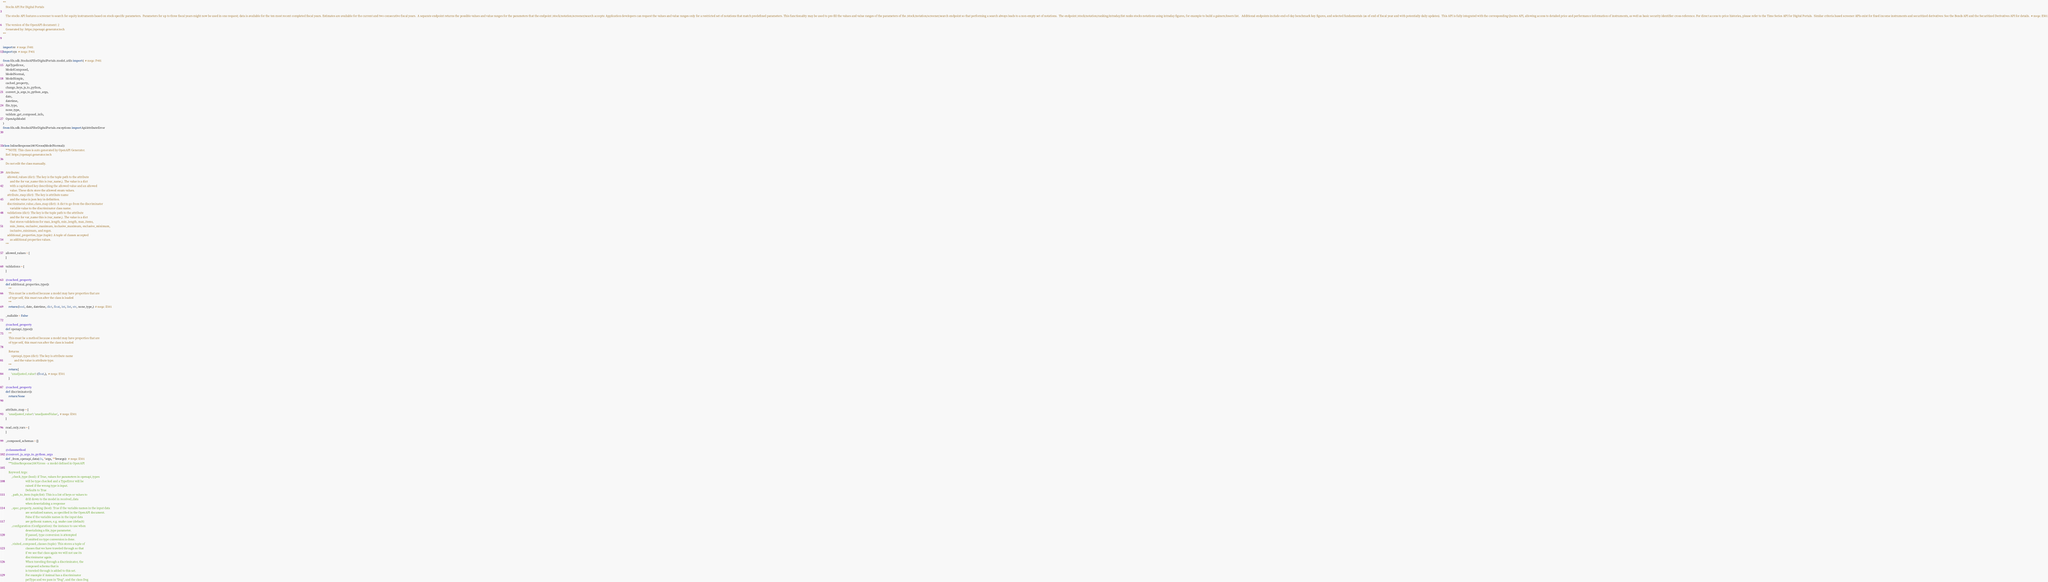Convert code to text. <code><loc_0><loc_0><loc_500><loc_500><_Python_>"""
    Stocks API For Digital Portals

    The stocks API features a screener to search for equity instruments based on stock-specific parameters.  Parameters for up to three fiscal years might now be used in one request; data is available for the ten most recent completed fiscal years. Estimates are available for the current and two consecutive fiscal years.  A separate endpoint returns the possible values and value ranges for the parameters that the endpoint /stock/notation/screener/search accepts: Application developers can request the values and value ranges only for a restricted set of notations that match predefined parameters. This functionality may be used to pre-fill the values and value ranges of the parameters of the /stock/notation/screener/search endpoint so that performing a search always leads to a non-empty set of notations.  The endpoint /stock/notation/ranking/intraday/list ranks stocks notations using intraday figures, for example to build a gainers/losers list.   Additional endpoints include end-of-day benchmark key figures, and selected fundamentals (as of end of fiscal year and with potentially daily updates).  This API is fully integrated with the corresponding Quotes API, allowing access to detailed price and performance information of instruments, as well as basic security identifier cross-reference. For direct access to price histories, please refer to the Time Series API for Digital Portals.  Similar criteria based screener APIs exist for fixed income instruments and securitized derivatives: See the Bonds API and the Securitized Derivatives API for details.  # noqa: E501

    The version of the OpenAPI document: 2
    Generated by: https://openapi-generator.tech
"""


import re  # noqa: F401
import sys  # noqa: F401

from fds.sdk.StocksAPIforDigitalPortals.model_utils import (  # noqa: F401
    ApiTypeError,
    ModelComposed,
    ModelNormal,
    ModelSimple,
    cached_property,
    change_keys_js_to_python,
    convert_js_args_to_python_args,
    date,
    datetime,
    file_type,
    none_type,
    validate_get_composed_info,
    OpenApiModel
)
from fds.sdk.StocksAPIforDigitalPortals.exceptions import ApiAttributeError



class InlineResponse2007Gross(ModelNormal):
    """NOTE: This class is auto generated by OpenAPI Generator.
    Ref: https://openapi-generator.tech

    Do not edit the class manually.

    Attributes:
      allowed_values (dict): The key is the tuple path to the attribute
          and the for var_name this is (var_name,). The value is a dict
          with a capitalized key describing the allowed value and an allowed
          value. These dicts store the allowed enum values.
      attribute_map (dict): The key is attribute name
          and the value is json key in definition.
      discriminator_value_class_map (dict): A dict to go from the discriminator
          variable value to the discriminator class name.
      validations (dict): The key is the tuple path to the attribute
          and the for var_name this is (var_name,). The value is a dict
          that stores validations for max_length, min_length, max_items,
          min_items, exclusive_maximum, inclusive_maximum, exclusive_minimum,
          inclusive_minimum, and regex.
      additional_properties_type (tuple): A tuple of classes accepted
          as additional properties values.
    """

    allowed_values = {
    }

    validations = {
    }

    @cached_property
    def additional_properties_type():
        """
        This must be a method because a model may have properties that are
        of type self, this must run after the class is loaded
        """
        return (bool, date, datetime, dict, float, int, list, str, none_type,)  # noqa: E501

    _nullable = False

    @cached_property
    def openapi_types():
        """
        This must be a method because a model may have properties that are
        of type self, this must run after the class is loaded

        Returns
            openapi_types (dict): The key is attribute name
                and the value is attribute type.
        """
        return {
            'unadjusted_value': (float,),  # noqa: E501
        }

    @cached_property
    def discriminator():
        return None


    attribute_map = {
        'unadjusted_value': 'unadjustedValue',  # noqa: E501
    }

    read_only_vars = {
    }

    _composed_schemas = {}

    @classmethod
    @convert_js_args_to_python_args
    def _from_openapi_data(cls, *args, **kwargs):  # noqa: E501
        """InlineResponse2007Gross - a model defined in OpenAPI

        Keyword Args:
            _check_type (bool): if True, values for parameters in openapi_types
                                will be type checked and a TypeError will be
                                raised if the wrong type is input.
                                Defaults to True
            _path_to_item (tuple/list): This is a list of keys or values to
                                drill down to the model in received_data
                                when deserializing a response
            _spec_property_naming (bool): True if the variable names in the input data
                                are serialized names, as specified in the OpenAPI document.
                                False if the variable names in the input data
                                are pythonic names, e.g. snake case (default)
            _configuration (Configuration): the instance to use when
                                deserializing a file_type parameter.
                                If passed, type conversion is attempted
                                If omitted no type conversion is done.
            _visited_composed_classes (tuple): This stores a tuple of
                                classes that we have traveled through so that
                                if we see that class again we will not use its
                                discriminator again.
                                When traveling through a discriminator, the
                                composed schema that is
                                is traveled through is added to this set.
                                For example if Animal has a discriminator
                                petType and we pass in "Dog", and the class Dog</code> 